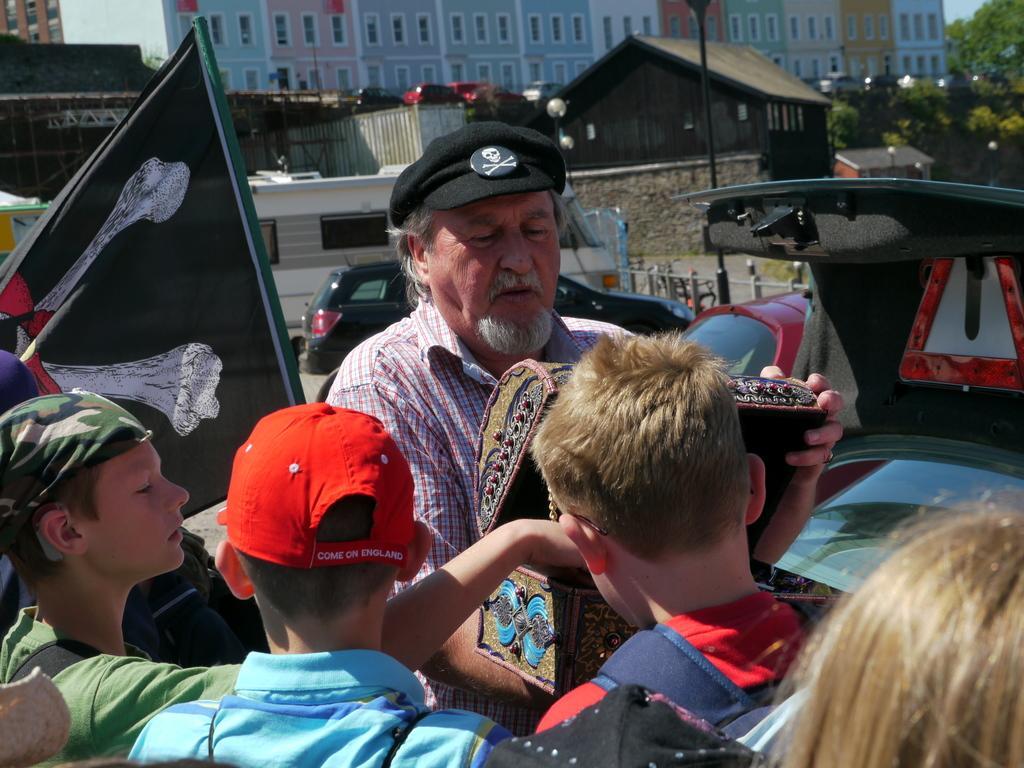Could you give a brief overview of what you see in this image? In front of the image there is a person holding a box, in front of him there are kids, behind the person there is a flag, cars, lamp posts, buildings and trees. 